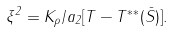<formula> <loc_0><loc_0><loc_500><loc_500>\xi ^ { 2 } = K _ { \rho } / a _ { 2 } [ T - T ^ { \ast \ast } ( \bar { S } ) ] .</formula> 